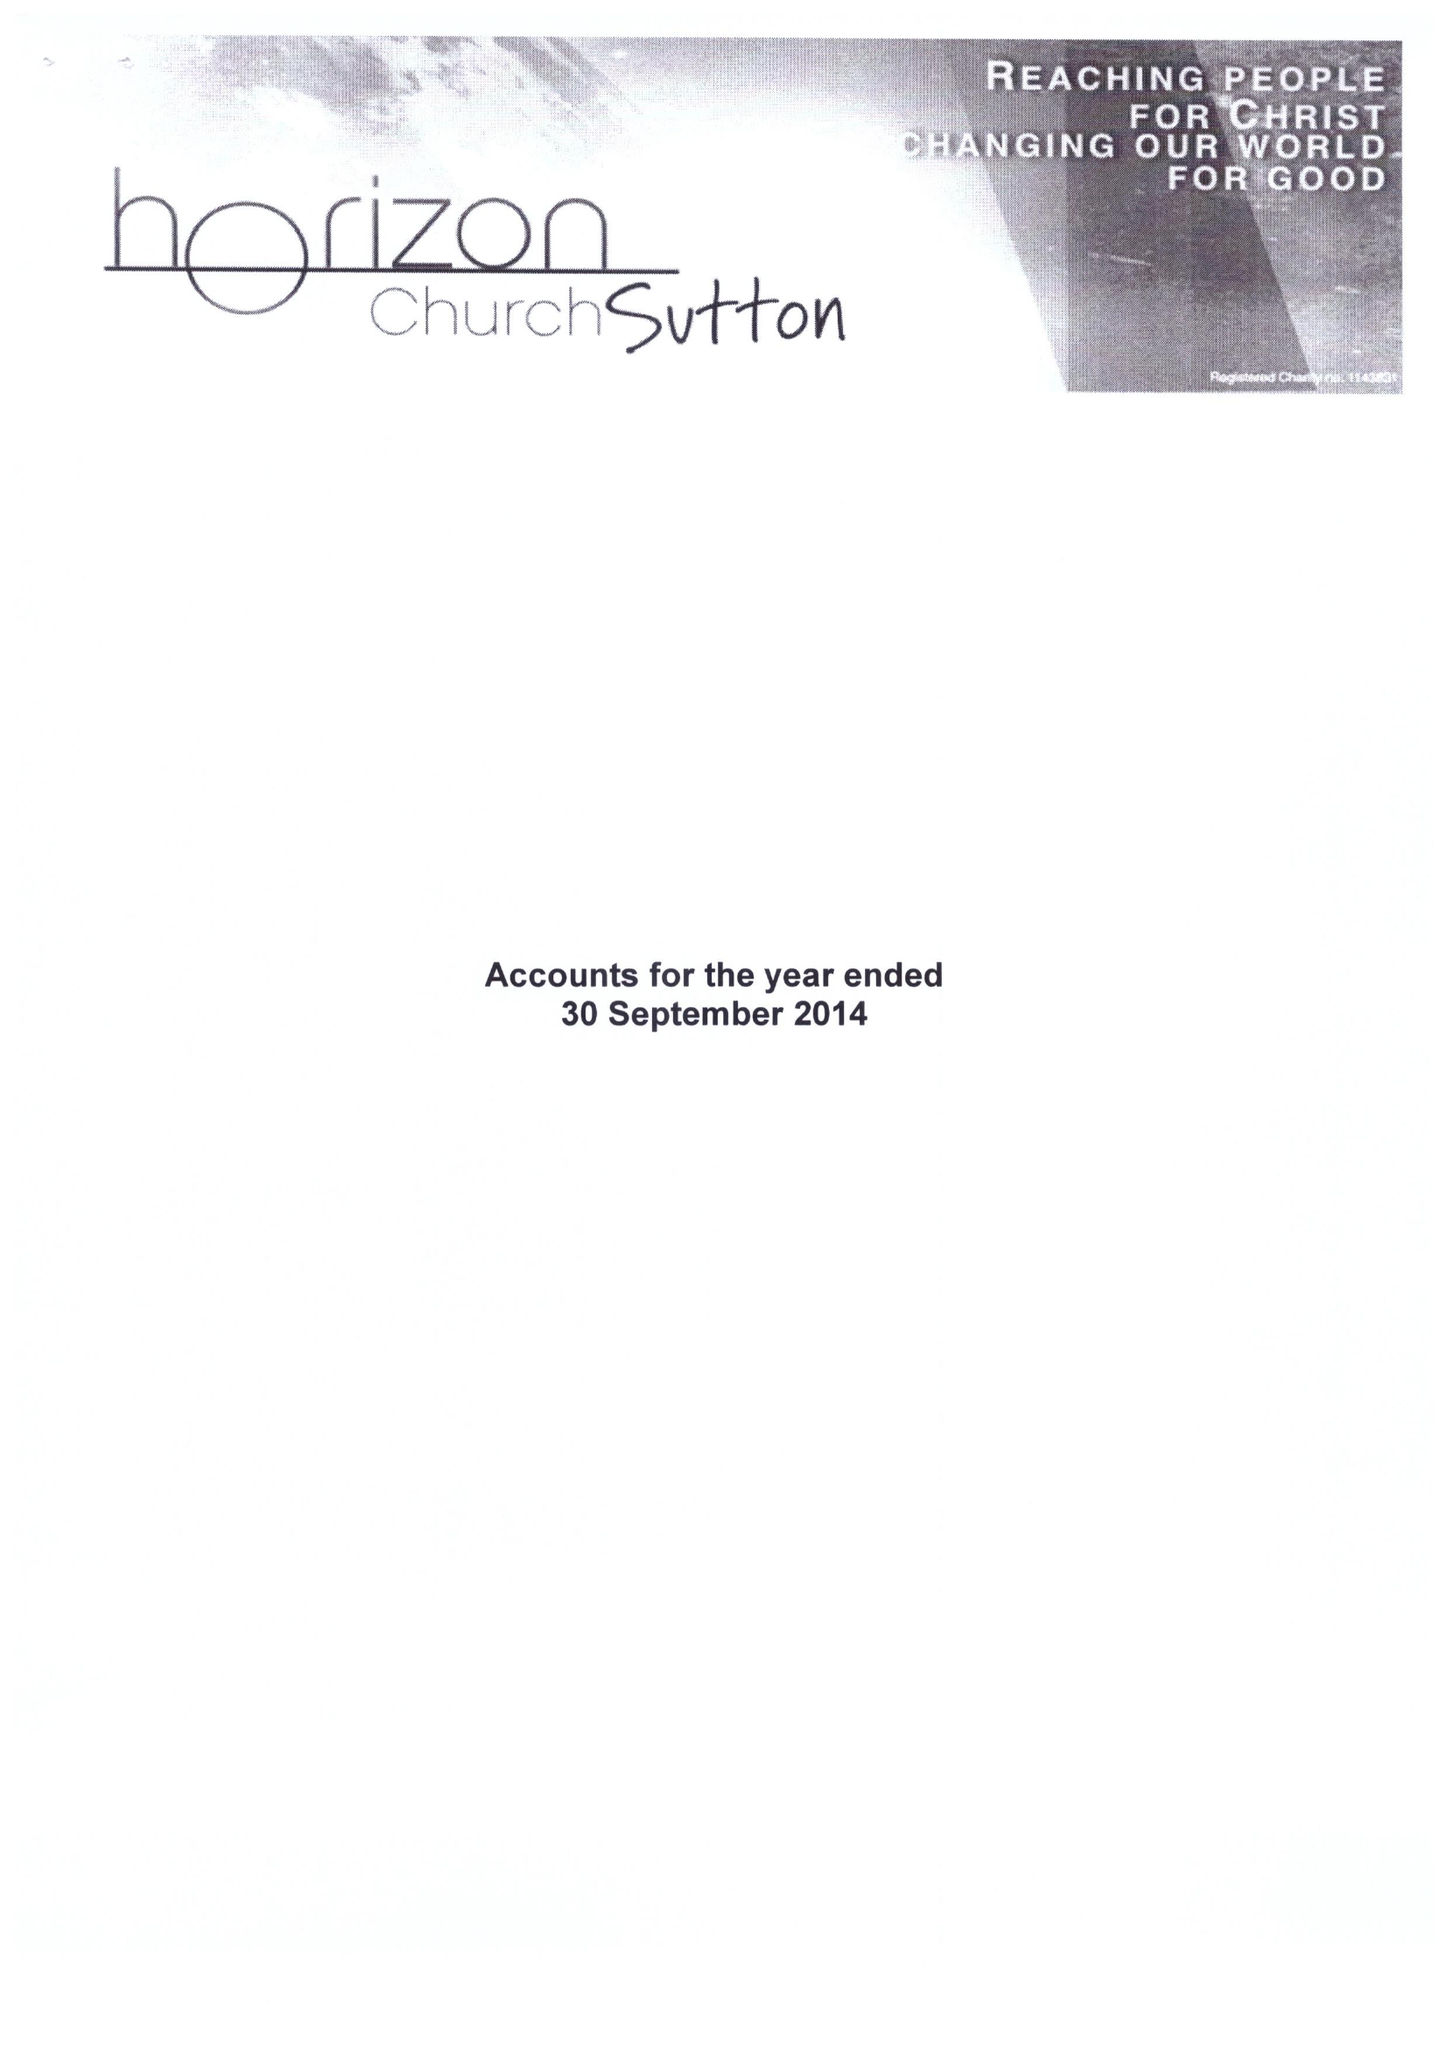What is the value for the address__postcode?
Answer the question using a single word or phrase. SM5 1JH 